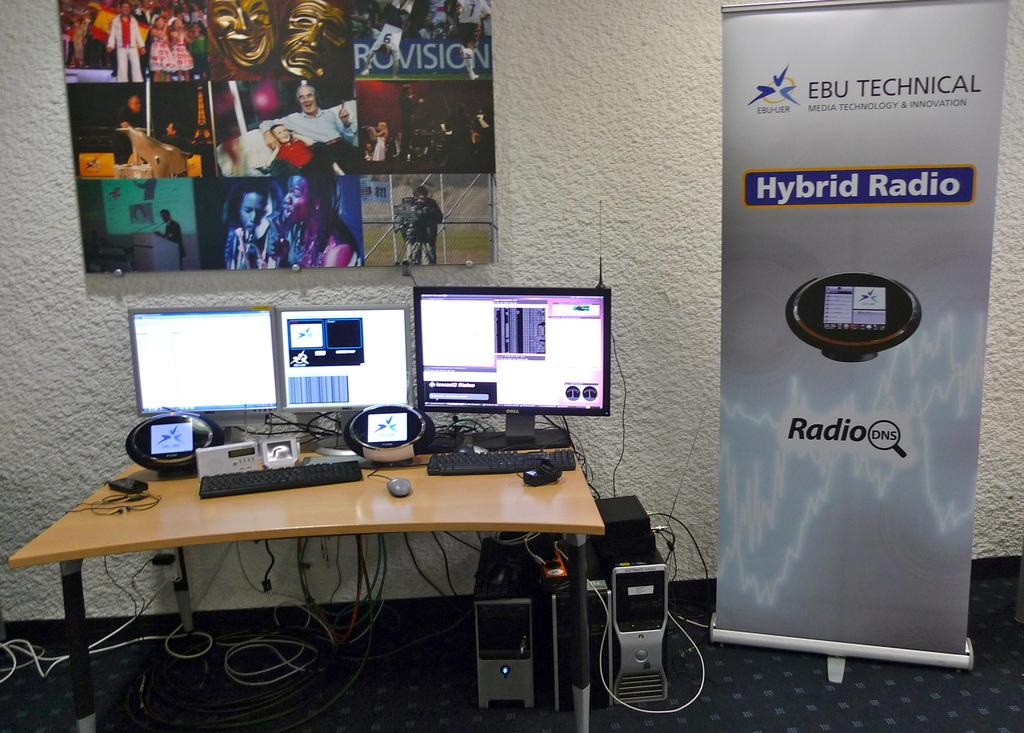What sort of radios is that?
Your answer should be compact. Hybrid. What's the company name that makes a radio?
Offer a very short reply. Ebu technical. 